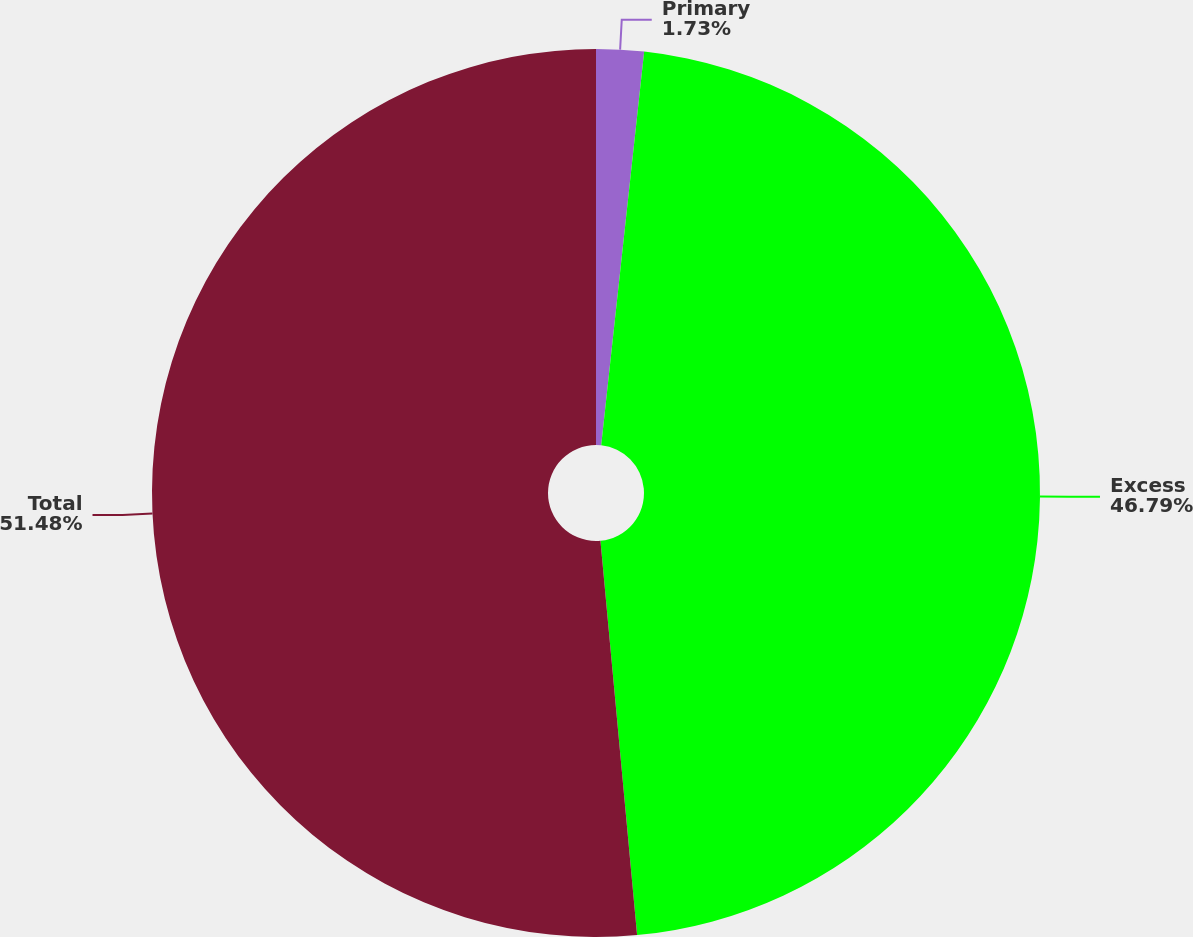Convert chart. <chart><loc_0><loc_0><loc_500><loc_500><pie_chart><fcel>Primary<fcel>Excess<fcel>Total<nl><fcel>1.73%<fcel>46.79%<fcel>51.47%<nl></chart> 